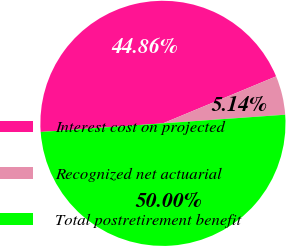Convert chart to OTSL. <chart><loc_0><loc_0><loc_500><loc_500><pie_chart><fcel>Interest cost on projected<fcel>Recognized net actuarial<fcel>Total postretirement benefit<nl><fcel>44.86%<fcel>5.14%<fcel>50.0%<nl></chart> 